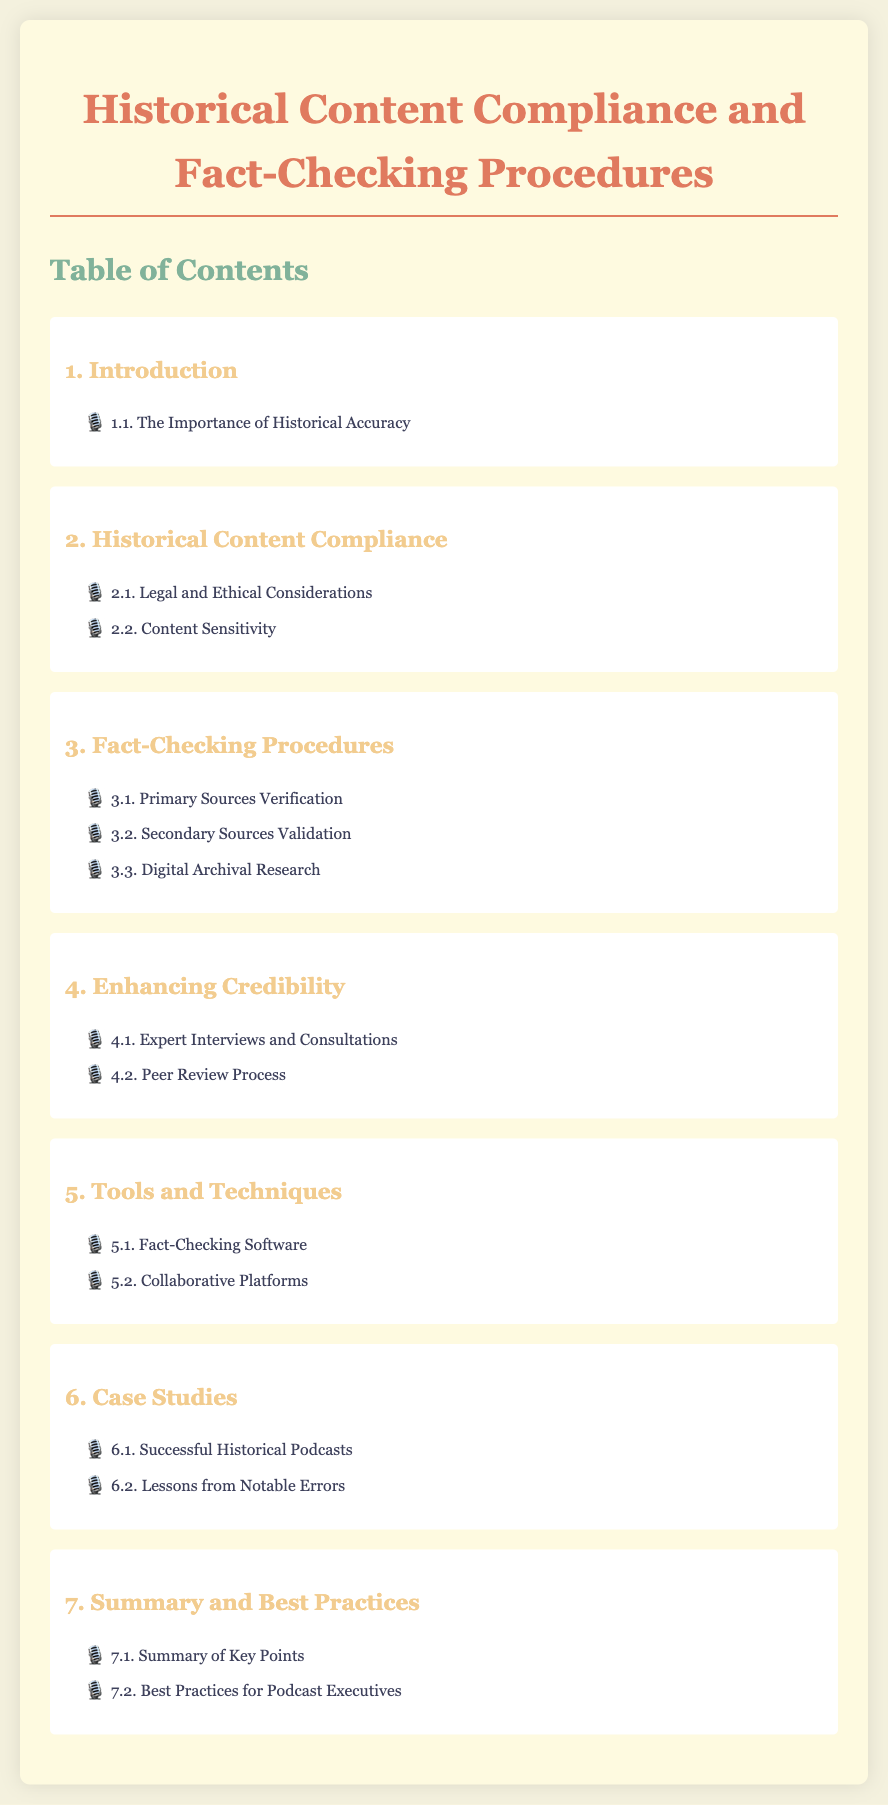What is the first section in the document? The first section in the document is listed in the Table of Contents, which is "Introduction."
Answer: Introduction What is covered under section 2? Section 2 is titled "Historical Content Compliance" and it includes two subtopics.
Answer: Legal and Ethical Considerations, Content Sensitivity How many subtopics are in the "Fact-Checking Procedures" section? The "Fact-Checking Procedures" section contains three subtopics.
Answer: 3 What is one method mentioned for enhancing credibility? The section on enhancing credibility outlines methods for improving reliability, such as expert input.
Answer: Expert Interviews and Consultations What is the last section number in this document? The last main section in the document is numbered as section 7, which encompasses various topics including best practices.
Answer: 7 